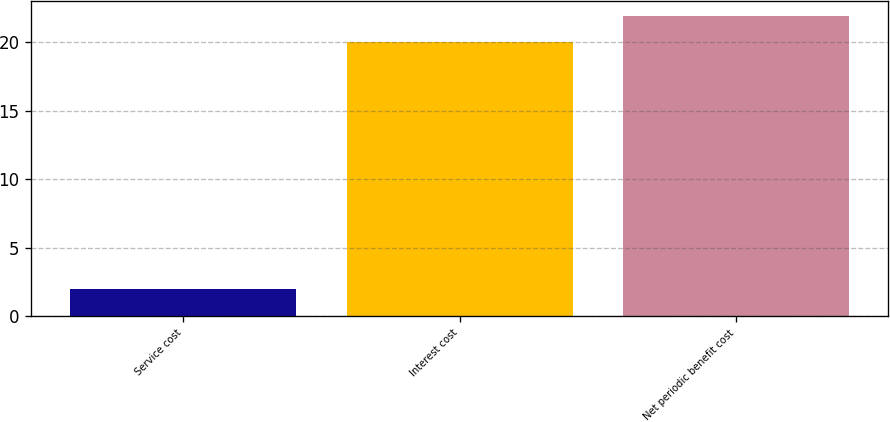Convert chart. <chart><loc_0><loc_0><loc_500><loc_500><bar_chart><fcel>Service cost<fcel>Interest cost<fcel>Net periodic benefit cost<nl><fcel>2<fcel>20<fcel>21.9<nl></chart> 